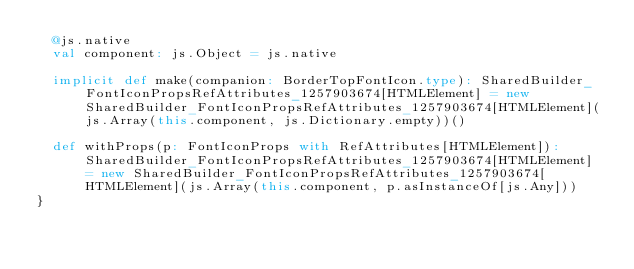Convert code to text. <code><loc_0><loc_0><loc_500><loc_500><_Scala_>  @js.native
  val component: js.Object = js.native
  
  implicit def make(companion: BorderTopFontIcon.type): SharedBuilder_FontIconPropsRefAttributes_1257903674[HTMLElement] = new SharedBuilder_FontIconPropsRefAttributes_1257903674[HTMLElement](js.Array(this.component, js.Dictionary.empty))()
  
  def withProps(p: FontIconProps with RefAttributes[HTMLElement]): SharedBuilder_FontIconPropsRefAttributes_1257903674[HTMLElement] = new SharedBuilder_FontIconPropsRefAttributes_1257903674[HTMLElement](js.Array(this.component, p.asInstanceOf[js.Any]))
}
</code> 